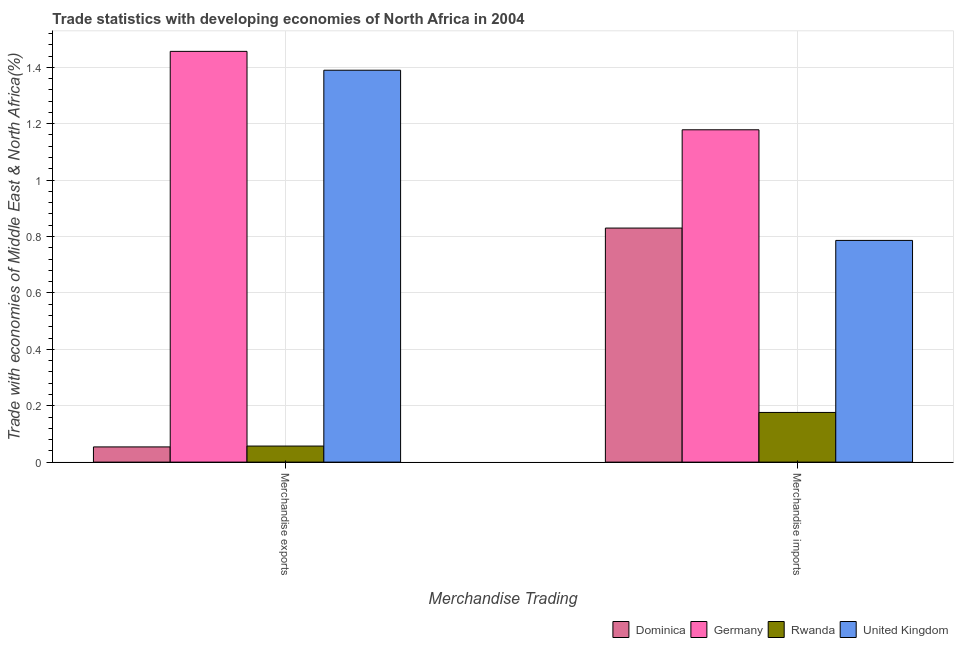How many different coloured bars are there?
Your response must be concise. 4. What is the label of the 1st group of bars from the left?
Ensure brevity in your answer.  Merchandise exports. What is the merchandise imports in Dominica?
Give a very brief answer. 0.83. Across all countries, what is the maximum merchandise imports?
Keep it short and to the point. 1.18. Across all countries, what is the minimum merchandise exports?
Give a very brief answer. 0.05. In which country was the merchandise exports maximum?
Your response must be concise. Germany. In which country was the merchandise exports minimum?
Make the answer very short. Dominica. What is the total merchandise exports in the graph?
Ensure brevity in your answer.  2.96. What is the difference between the merchandise exports in Dominica and that in Germany?
Provide a short and direct response. -1.4. What is the difference between the merchandise exports in Rwanda and the merchandise imports in Germany?
Your answer should be compact. -1.12. What is the average merchandise imports per country?
Your response must be concise. 0.74. What is the difference between the merchandise imports and merchandise exports in Rwanda?
Provide a succinct answer. 0.12. What is the ratio of the merchandise exports in Rwanda to that in Dominica?
Make the answer very short. 1.06. What does the 1st bar from the left in Merchandise imports represents?
Give a very brief answer. Dominica. Are all the bars in the graph horizontal?
Offer a terse response. No. What is the difference between two consecutive major ticks on the Y-axis?
Your answer should be very brief. 0.2. Are the values on the major ticks of Y-axis written in scientific E-notation?
Ensure brevity in your answer.  No. How many legend labels are there?
Ensure brevity in your answer.  4. What is the title of the graph?
Your response must be concise. Trade statistics with developing economies of North Africa in 2004. What is the label or title of the X-axis?
Provide a short and direct response. Merchandise Trading. What is the label or title of the Y-axis?
Provide a short and direct response. Trade with economies of Middle East & North Africa(%). What is the Trade with economies of Middle East & North Africa(%) in Dominica in Merchandise exports?
Give a very brief answer. 0.05. What is the Trade with economies of Middle East & North Africa(%) in Germany in Merchandise exports?
Your answer should be compact. 1.46. What is the Trade with economies of Middle East & North Africa(%) of Rwanda in Merchandise exports?
Keep it short and to the point. 0.06. What is the Trade with economies of Middle East & North Africa(%) in United Kingdom in Merchandise exports?
Your response must be concise. 1.39. What is the Trade with economies of Middle East & North Africa(%) in Dominica in Merchandise imports?
Ensure brevity in your answer.  0.83. What is the Trade with economies of Middle East & North Africa(%) in Germany in Merchandise imports?
Your response must be concise. 1.18. What is the Trade with economies of Middle East & North Africa(%) in Rwanda in Merchandise imports?
Give a very brief answer. 0.18. What is the Trade with economies of Middle East & North Africa(%) of United Kingdom in Merchandise imports?
Give a very brief answer. 0.79. Across all Merchandise Trading, what is the maximum Trade with economies of Middle East & North Africa(%) in Dominica?
Provide a succinct answer. 0.83. Across all Merchandise Trading, what is the maximum Trade with economies of Middle East & North Africa(%) of Germany?
Make the answer very short. 1.46. Across all Merchandise Trading, what is the maximum Trade with economies of Middle East & North Africa(%) in Rwanda?
Offer a very short reply. 0.18. Across all Merchandise Trading, what is the maximum Trade with economies of Middle East & North Africa(%) in United Kingdom?
Give a very brief answer. 1.39. Across all Merchandise Trading, what is the minimum Trade with economies of Middle East & North Africa(%) in Dominica?
Offer a very short reply. 0.05. Across all Merchandise Trading, what is the minimum Trade with economies of Middle East & North Africa(%) in Germany?
Your answer should be very brief. 1.18. Across all Merchandise Trading, what is the minimum Trade with economies of Middle East & North Africa(%) in Rwanda?
Provide a short and direct response. 0.06. Across all Merchandise Trading, what is the minimum Trade with economies of Middle East & North Africa(%) in United Kingdom?
Give a very brief answer. 0.79. What is the total Trade with economies of Middle East & North Africa(%) in Dominica in the graph?
Offer a terse response. 0.88. What is the total Trade with economies of Middle East & North Africa(%) of Germany in the graph?
Keep it short and to the point. 2.63. What is the total Trade with economies of Middle East & North Africa(%) in Rwanda in the graph?
Your answer should be very brief. 0.23. What is the total Trade with economies of Middle East & North Africa(%) in United Kingdom in the graph?
Your answer should be compact. 2.18. What is the difference between the Trade with economies of Middle East & North Africa(%) of Dominica in Merchandise exports and that in Merchandise imports?
Your answer should be compact. -0.78. What is the difference between the Trade with economies of Middle East & North Africa(%) in Germany in Merchandise exports and that in Merchandise imports?
Offer a very short reply. 0.28. What is the difference between the Trade with economies of Middle East & North Africa(%) of Rwanda in Merchandise exports and that in Merchandise imports?
Your answer should be very brief. -0.12. What is the difference between the Trade with economies of Middle East & North Africa(%) of United Kingdom in Merchandise exports and that in Merchandise imports?
Offer a terse response. 0.6. What is the difference between the Trade with economies of Middle East & North Africa(%) in Dominica in Merchandise exports and the Trade with economies of Middle East & North Africa(%) in Germany in Merchandise imports?
Your answer should be very brief. -1.12. What is the difference between the Trade with economies of Middle East & North Africa(%) in Dominica in Merchandise exports and the Trade with economies of Middle East & North Africa(%) in Rwanda in Merchandise imports?
Provide a short and direct response. -0.12. What is the difference between the Trade with economies of Middle East & North Africa(%) in Dominica in Merchandise exports and the Trade with economies of Middle East & North Africa(%) in United Kingdom in Merchandise imports?
Offer a very short reply. -0.73. What is the difference between the Trade with economies of Middle East & North Africa(%) in Germany in Merchandise exports and the Trade with economies of Middle East & North Africa(%) in Rwanda in Merchandise imports?
Your response must be concise. 1.28. What is the difference between the Trade with economies of Middle East & North Africa(%) in Germany in Merchandise exports and the Trade with economies of Middle East & North Africa(%) in United Kingdom in Merchandise imports?
Your answer should be very brief. 0.67. What is the difference between the Trade with economies of Middle East & North Africa(%) in Rwanda in Merchandise exports and the Trade with economies of Middle East & North Africa(%) in United Kingdom in Merchandise imports?
Offer a terse response. -0.73. What is the average Trade with economies of Middle East & North Africa(%) of Dominica per Merchandise Trading?
Provide a short and direct response. 0.44. What is the average Trade with economies of Middle East & North Africa(%) of Germany per Merchandise Trading?
Your response must be concise. 1.32. What is the average Trade with economies of Middle East & North Africa(%) of Rwanda per Merchandise Trading?
Provide a short and direct response. 0.12. What is the average Trade with economies of Middle East & North Africa(%) of United Kingdom per Merchandise Trading?
Provide a short and direct response. 1.09. What is the difference between the Trade with economies of Middle East & North Africa(%) in Dominica and Trade with economies of Middle East & North Africa(%) in Germany in Merchandise exports?
Provide a succinct answer. -1.4. What is the difference between the Trade with economies of Middle East & North Africa(%) in Dominica and Trade with economies of Middle East & North Africa(%) in Rwanda in Merchandise exports?
Keep it short and to the point. -0. What is the difference between the Trade with economies of Middle East & North Africa(%) in Dominica and Trade with economies of Middle East & North Africa(%) in United Kingdom in Merchandise exports?
Provide a succinct answer. -1.34. What is the difference between the Trade with economies of Middle East & North Africa(%) in Germany and Trade with economies of Middle East & North Africa(%) in Rwanda in Merchandise exports?
Your response must be concise. 1.4. What is the difference between the Trade with economies of Middle East & North Africa(%) in Germany and Trade with economies of Middle East & North Africa(%) in United Kingdom in Merchandise exports?
Offer a very short reply. 0.07. What is the difference between the Trade with economies of Middle East & North Africa(%) in Rwanda and Trade with economies of Middle East & North Africa(%) in United Kingdom in Merchandise exports?
Provide a short and direct response. -1.33. What is the difference between the Trade with economies of Middle East & North Africa(%) of Dominica and Trade with economies of Middle East & North Africa(%) of Germany in Merchandise imports?
Your response must be concise. -0.35. What is the difference between the Trade with economies of Middle East & North Africa(%) in Dominica and Trade with economies of Middle East & North Africa(%) in Rwanda in Merchandise imports?
Your answer should be compact. 0.65. What is the difference between the Trade with economies of Middle East & North Africa(%) in Dominica and Trade with economies of Middle East & North Africa(%) in United Kingdom in Merchandise imports?
Keep it short and to the point. 0.04. What is the difference between the Trade with economies of Middle East & North Africa(%) of Germany and Trade with economies of Middle East & North Africa(%) of United Kingdom in Merchandise imports?
Your answer should be very brief. 0.39. What is the difference between the Trade with economies of Middle East & North Africa(%) in Rwanda and Trade with economies of Middle East & North Africa(%) in United Kingdom in Merchandise imports?
Provide a short and direct response. -0.61. What is the ratio of the Trade with economies of Middle East & North Africa(%) in Dominica in Merchandise exports to that in Merchandise imports?
Provide a succinct answer. 0.07. What is the ratio of the Trade with economies of Middle East & North Africa(%) in Germany in Merchandise exports to that in Merchandise imports?
Offer a terse response. 1.24. What is the ratio of the Trade with economies of Middle East & North Africa(%) of Rwanda in Merchandise exports to that in Merchandise imports?
Your answer should be very brief. 0.32. What is the ratio of the Trade with economies of Middle East & North Africa(%) in United Kingdom in Merchandise exports to that in Merchandise imports?
Your answer should be compact. 1.77. What is the difference between the highest and the second highest Trade with economies of Middle East & North Africa(%) in Dominica?
Provide a short and direct response. 0.78. What is the difference between the highest and the second highest Trade with economies of Middle East & North Africa(%) of Germany?
Your answer should be compact. 0.28. What is the difference between the highest and the second highest Trade with economies of Middle East & North Africa(%) of Rwanda?
Ensure brevity in your answer.  0.12. What is the difference between the highest and the second highest Trade with economies of Middle East & North Africa(%) in United Kingdom?
Offer a very short reply. 0.6. What is the difference between the highest and the lowest Trade with economies of Middle East & North Africa(%) of Dominica?
Ensure brevity in your answer.  0.78. What is the difference between the highest and the lowest Trade with economies of Middle East & North Africa(%) of Germany?
Keep it short and to the point. 0.28. What is the difference between the highest and the lowest Trade with economies of Middle East & North Africa(%) of Rwanda?
Offer a terse response. 0.12. What is the difference between the highest and the lowest Trade with economies of Middle East & North Africa(%) of United Kingdom?
Keep it short and to the point. 0.6. 